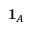<formula> <loc_0><loc_0><loc_500><loc_500>1 _ { A }</formula> 